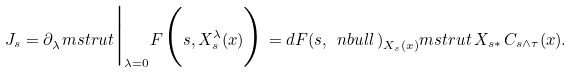Convert formula to latex. <formula><loc_0><loc_0><loc_500><loc_500>J _ { s } = \partial _ { \lambda } ^ { \ } m s t r u t \Big | _ { \lambda = 0 } F \Big ( s , X ^ { \lambda } _ { s } ( x ) \Big ) = d F ( s , \ n b u l l \, ) _ { X _ { s } ( x ) } ^ { \ } m s t r u t \, X _ { s \ast } \, C _ { s \wedge \tau } ( x ) .</formula> 